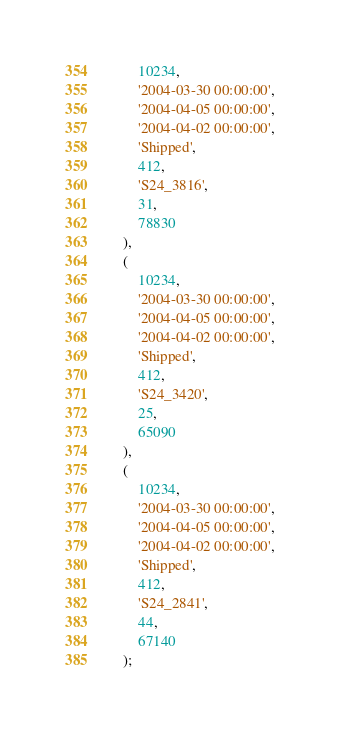<code> <loc_0><loc_0><loc_500><loc_500><_SQL_>        10234,
        '2004-03-30 00:00:00',
        '2004-04-05 00:00:00',
        '2004-04-02 00:00:00',
        'Shipped',
        412,
        'S24_3816',
        31,
        78830
    ),
    (
        10234,
        '2004-03-30 00:00:00',
        '2004-04-05 00:00:00',
        '2004-04-02 00:00:00',
        'Shipped',
        412,
        'S24_3420',
        25,
        65090
    ),
    (
        10234,
        '2004-03-30 00:00:00',
        '2004-04-05 00:00:00',
        '2004-04-02 00:00:00',
        'Shipped',
        412,
        'S24_2841',
        44,
        67140
    );</code> 